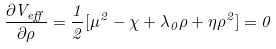<formula> <loc_0><loc_0><loc_500><loc_500>\frac { \partial V _ { e f f } } { \partial \rho } = \frac { 1 } { 2 } [ \mu ^ { 2 } - \chi + \lambda _ { 0 } \rho + \eta \rho ^ { 2 } ] = 0</formula> 